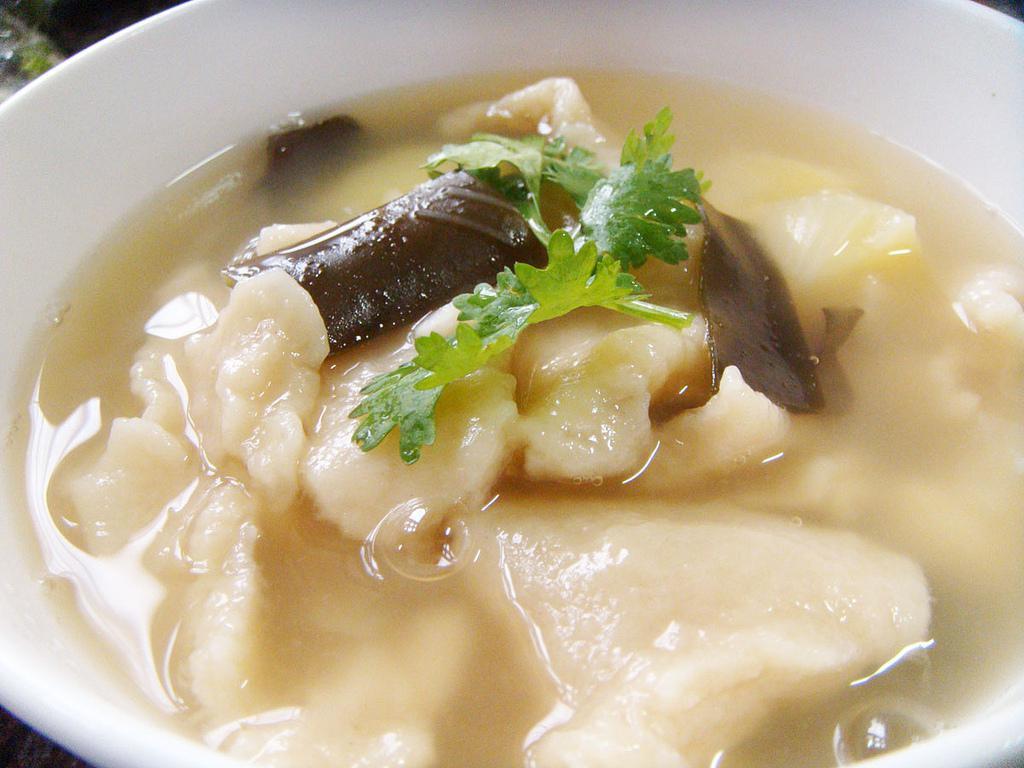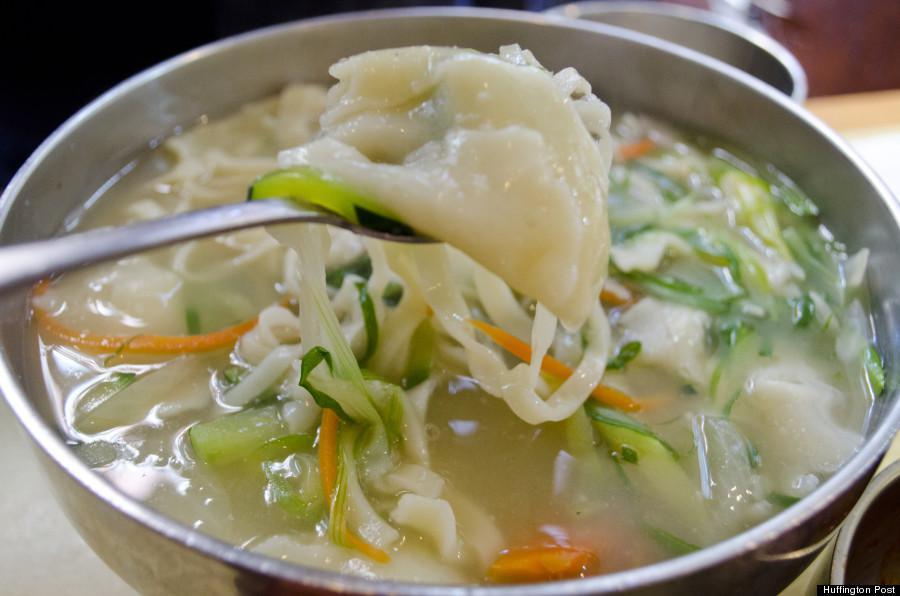The first image is the image on the left, the second image is the image on the right. Evaluate the accuracy of this statement regarding the images: "A metal spoon is over a round container of broth and other ingredients in one image.". Is it true? Answer yes or no. Yes. The first image is the image on the left, the second image is the image on the right. For the images displayed, is the sentence "There is a single white bowl in the left image." factually correct? Answer yes or no. Yes. 